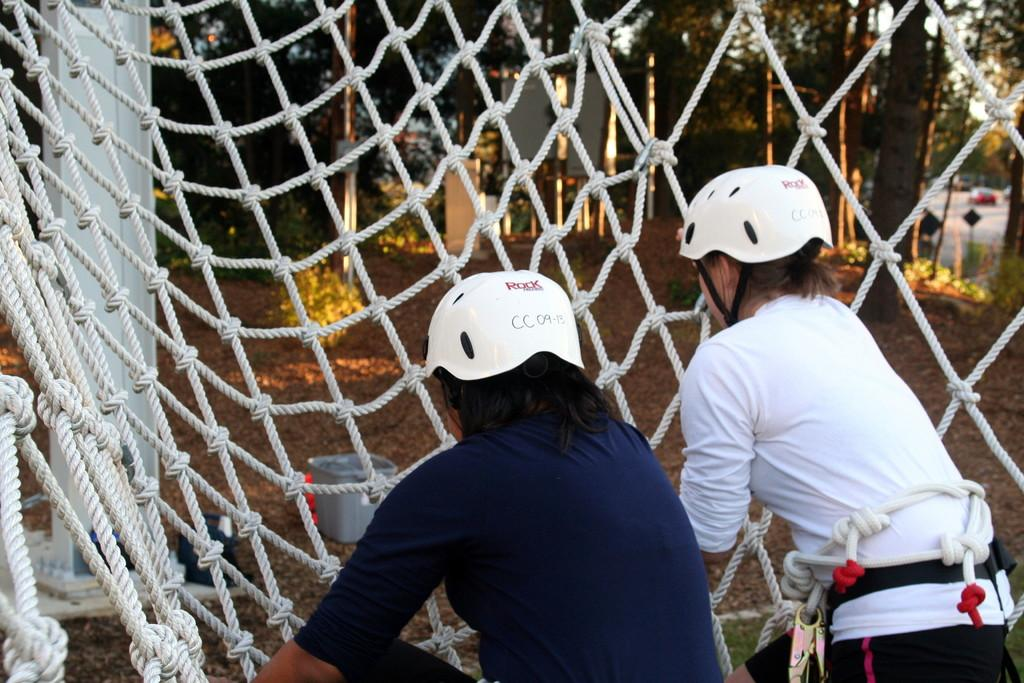How many people are in the image? There are 2 people in the image. What are the people wearing on their heads? The people are wearing white helmets. What is located beneath the people in the image? There is a white rope net beneath the people. What type of natural environment can be seen in the image? There are trees visible in the image. What can be seen in the background of the image? There is a container in the background of the image. What type of rings can be seen on the people's fingers in the image? There are no rings visible on the people's fingers in the image. Where is the lock located in the image? There is no lock present in the image. 